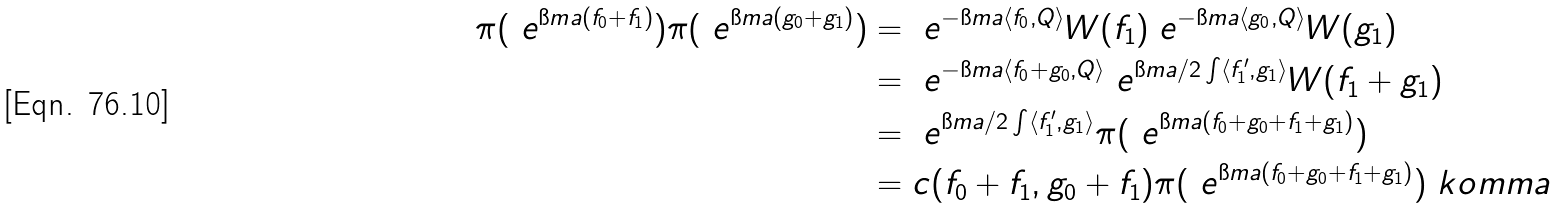Convert formula to latex. <formula><loc_0><loc_0><loc_500><loc_500>\pi ( \ e ^ { \i m a ( f _ { 0 } + f _ { 1 } ) } ) \pi ( \ e ^ { \i m a ( g _ { 0 } + g _ { 1 } ) } ) & = \ e ^ { - \i m a \langle f _ { 0 } , Q \rangle } W ( f _ { 1 } ) \ e ^ { - \i m a \langle g _ { 0 } , Q \rangle } W ( g _ { 1 } ) \\ & = \ e ^ { - \i m a \langle f _ { 0 } + g _ { 0 } , Q \rangle } \ e ^ { \i m a / 2 \int \langle f _ { 1 } ^ { \prime } , g _ { 1 } \rangle } W ( f _ { 1 } + g _ { 1 } ) \\ & = \ e ^ { \i m a / 2 \int \langle f _ { 1 } ^ { \prime } , g _ { 1 } \rangle } \pi ( \ e ^ { \i m a ( f _ { 0 } + g _ { 0 } + f _ { 1 } + g _ { 1 } ) } ) \\ & = c ( f _ { 0 } + f _ { 1 } , g _ { 0 } + f _ { 1 } ) \pi ( \ e ^ { \i m a ( f _ { 0 } + g _ { 0 } + f _ { 1 } + g _ { 1 } ) } ) \ k o m m a</formula> 